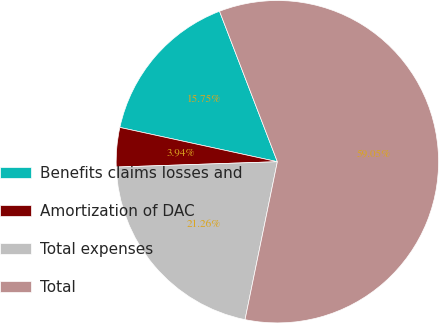<chart> <loc_0><loc_0><loc_500><loc_500><pie_chart><fcel>Benefits claims losses and<fcel>Amortization of DAC<fcel>Total expenses<fcel>Total<nl><fcel>15.75%<fcel>3.94%<fcel>21.26%<fcel>59.06%<nl></chart> 